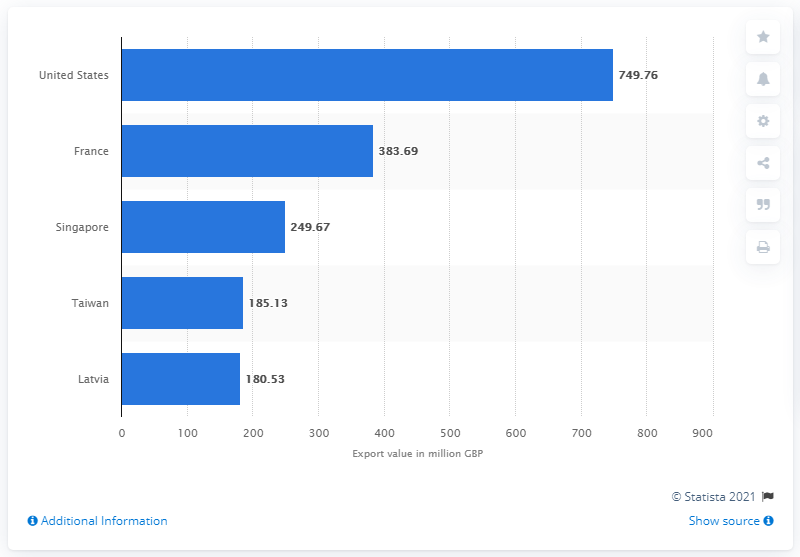Give some essential details in this illustration. France is the country that exports the most whisky. 